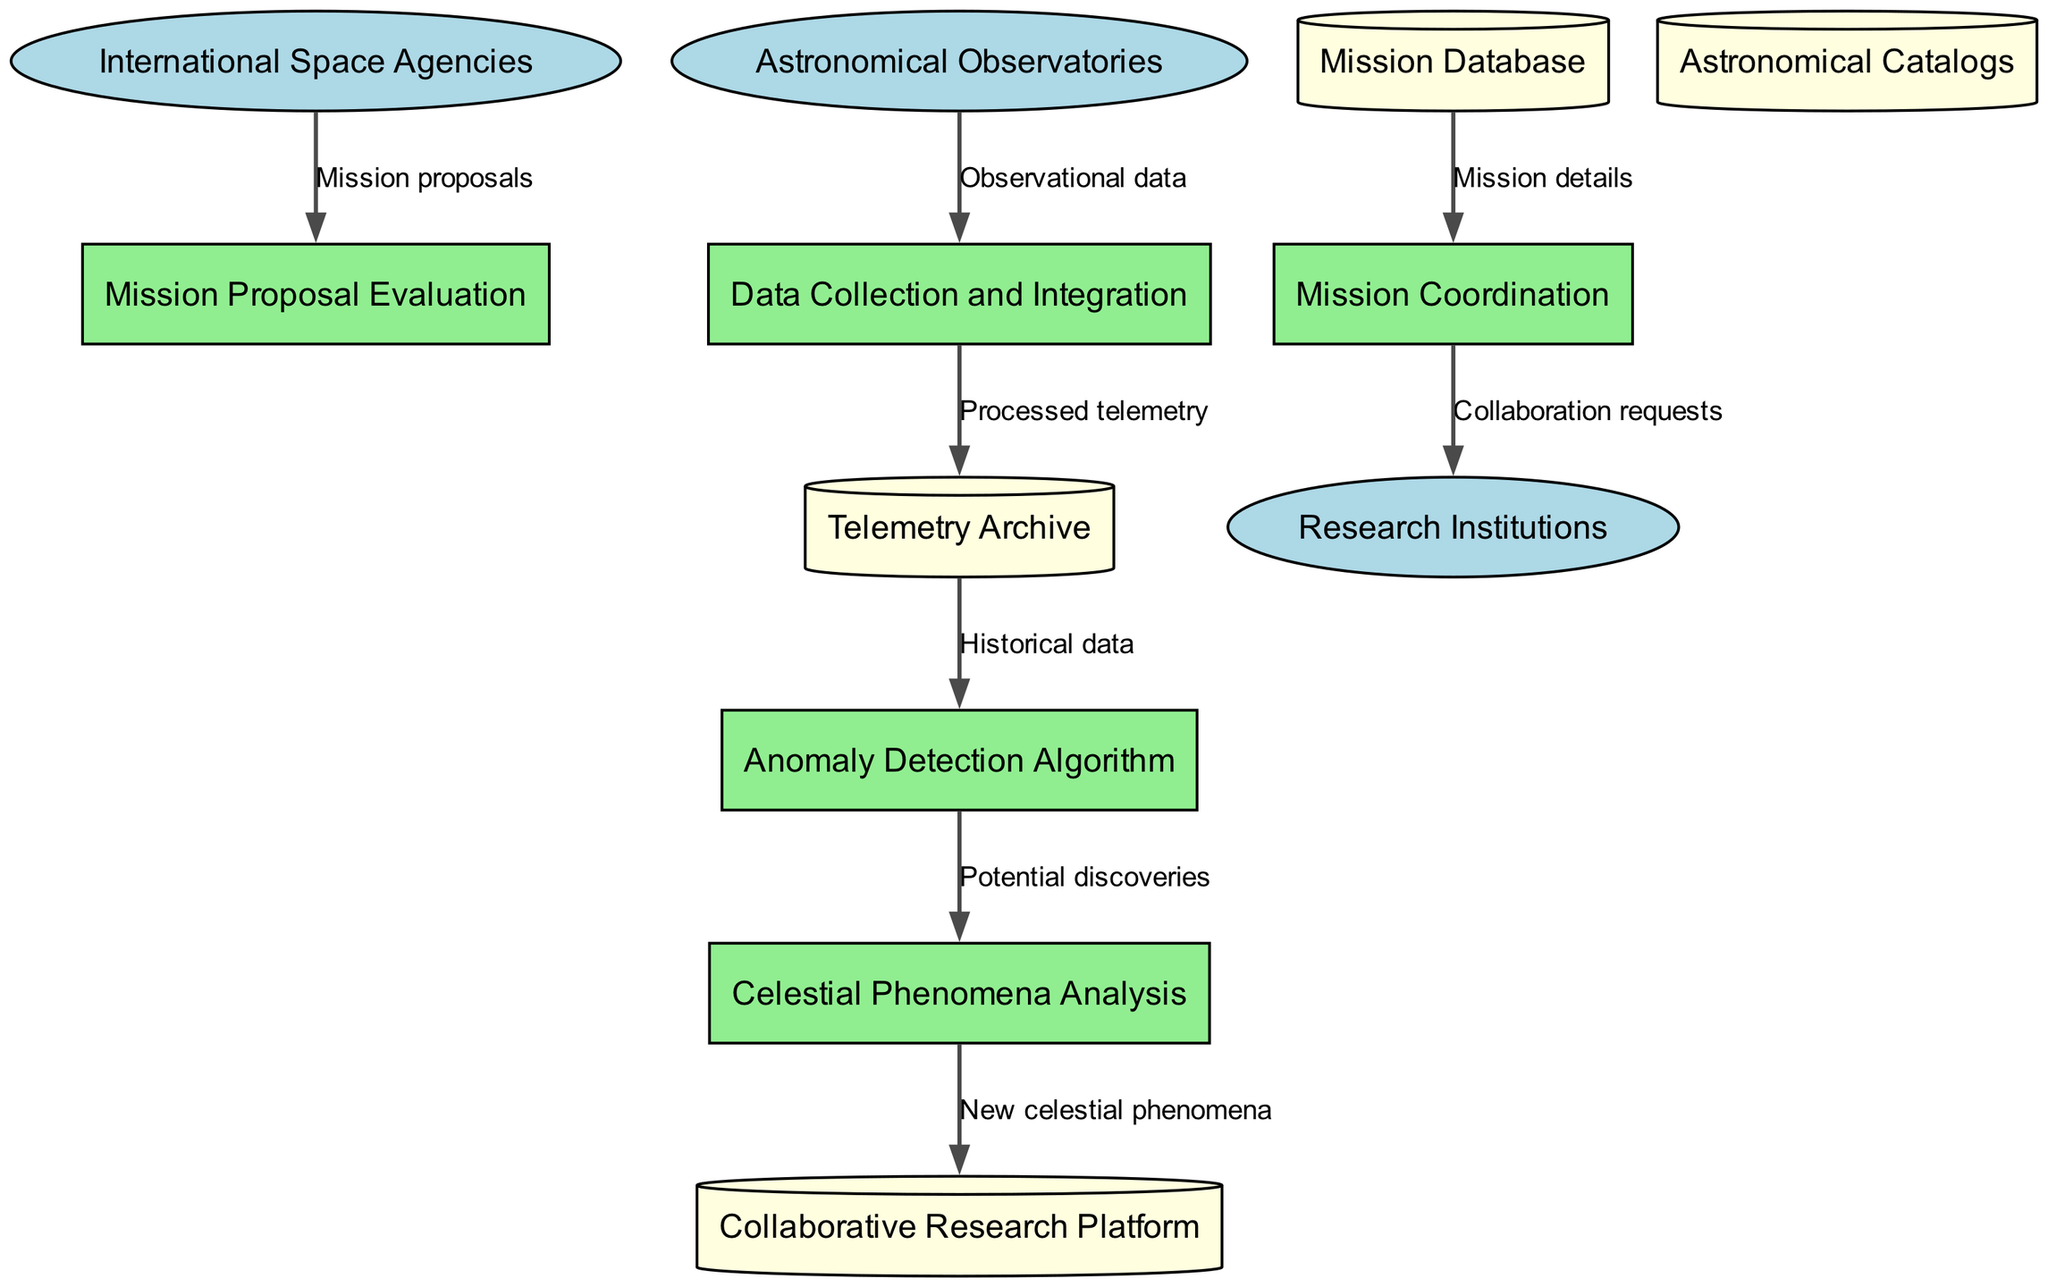What are the external entities in the diagram? The external entities are listed as part of the diagram nodes represented in light blue ellipses. They include International Space Agencies, Astronomical Observatories, and Research Institutions.
Answer: International Space Agencies, Astronomical Observatories, Research Institutions How many processes are represented in the diagram? The processes can be counted based on the green rectangle nodes labeled in the diagram. There are five processes: Mission Proposal Evaluation, Data Collection and Integration, Anomaly Detection Algorithm, Celestial Phenomena Analysis, and Mission Coordination.
Answer: Five Which process receives observational data? By examining the data flows, the process labeled "Data Collection and Integration" is specifically indicated to receive data from the "Astronomical Observatories," as shown by the corresponding flow.
Answer: Data Collection and Integration What flows from the Telemetry Archive to the next process? The data flow from the Telemetry Archive is labeled "Historical data," pointing to the "Anomaly Detection Algorithm" process. This indicates the specific information being transmitted between those two nodes.
Answer: Historical data Which external entity sends mission proposals? The diagram shows that the "International Space Agencies" send "Mission proposals" to the "Mission Proposal Evaluation" process, indicating the source of that particular input.
Answer: International Space Agencies Which data store is connected to Mission Coordination? The "Mission Database" is indicated as the data store that provides "Mission details" to the "Mission Coordination" process, establishing a clear relationship between the nodes.
Answer: Mission Database What is the output of the Celestial Phenomena Analysis process? The output of the "Celestial Phenomena Analysis" process is labeled "New celestial phenomena," which flows to the "Collaborative Research Platform," indicating what this process contributes.
Answer: New celestial phenomena How many edges are leaving the Anomaly Detection Algorithm? By reviewing the outgoing flows from the "Anomaly Detection Algorithm" node, there is one edge leading to the "Celestial Phenomena Analysis" process, confirming the number of connections.
Answer: One Which process does the Mission Database connect to? The data flow clearly illustrates that the "Mission Database" connects to the "Mission Coordination" process, as it supplies mission-related information to facilitate coordination.
Answer: Mission Coordination 